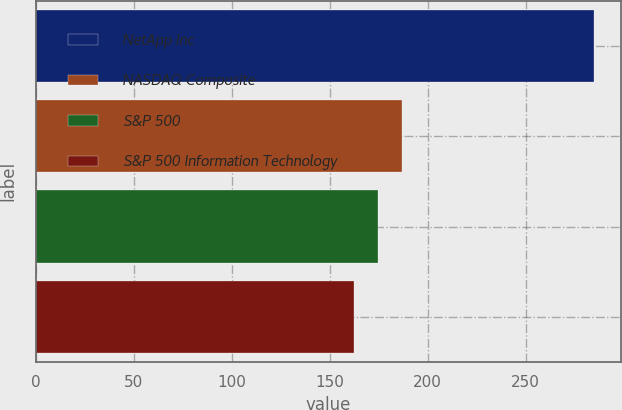Convert chart. <chart><loc_0><loc_0><loc_500><loc_500><bar_chart><fcel>NetApp Inc<fcel>NASDAQ Composite<fcel>S&P 500<fcel>S&P 500 Information Technology<nl><fcel>284.75<fcel>186.85<fcel>174.61<fcel>162.37<nl></chart> 